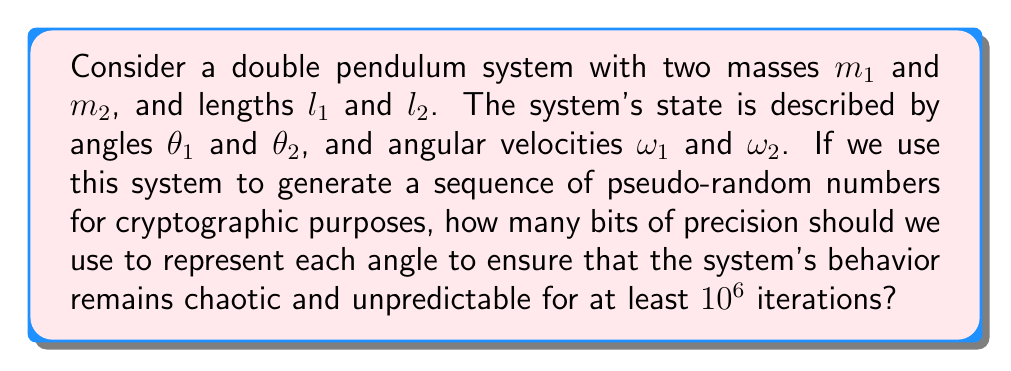Can you answer this question? To answer this question, we need to consider the following steps:

1. Understand the Lyapunov exponent:
The Lyapunov exponent $\lambda$ measures the rate of divergence of nearby trajectories in a dynamical system. For a chaotic system, $\lambda > 0$.

2. Estimate the Lyapunov exponent for a double pendulum:
The Lyapunov exponent for a typical double pendulum is approximately $\lambda \approx 2.5$ per second.

3. Calculate the number of iterations before predictability:
The number of iterations $N$ before the system becomes predictable is given by:

$$N \approx \frac{\log_2(2^b)}{\lambda \Delta t}$$

Where $b$ is the number of bits of precision, and $\Delta t$ is the time step between iterations.

4. Set $N = 10^6$ and solve for $b$:

$$10^6 \approx \frac{b}{\lambda \Delta t}$$

$$b \approx 10^6 \lambda \Delta t$$

5. Estimate a reasonable time step:
Let's assume a time step of $\Delta t = 0.01$ seconds.

6. Calculate the required number of bits:

$$b \approx 10^6 \cdot 2.5 \cdot 0.01 = 25,000 \text{ bits}$$

7. Round up to the nearest standard bit size:
The nearest standard bit size above 25,000 is 32,768 bits (2^15).

Therefore, to ensure chaotic behavior for at least $10^6$ iterations, we should use 32,768 bits (4,096 bytes) of precision for each angle in the double pendulum system.
Answer: 32,768 bits 